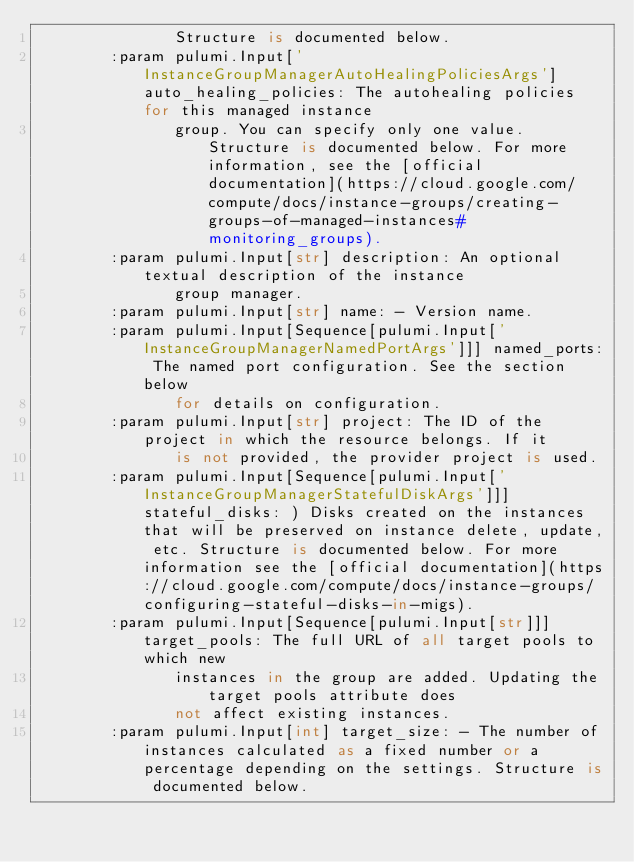Convert code to text. <code><loc_0><loc_0><loc_500><loc_500><_Python_>               Structure is documented below.
        :param pulumi.Input['InstanceGroupManagerAutoHealingPoliciesArgs'] auto_healing_policies: The autohealing policies for this managed instance
               group. You can specify only one value. Structure is documented below. For more information, see the [official documentation](https://cloud.google.com/compute/docs/instance-groups/creating-groups-of-managed-instances#monitoring_groups).
        :param pulumi.Input[str] description: An optional textual description of the instance
               group manager.
        :param pulumi.Input[str] name: - Version name.
        :param pulumi.Input[Sequence[pulumi.Input['InstanceGroupManagerNamedPortArgs']]] named_ports: The named port configuration. See the section below
               for details on configuration.
        :param pulumi.Input[str] project: The ID of the project in which the resource belongs. If it
               is not provided, the provider project is used.
        :param pulumi.Input[Sequence[pulumi.Input['InstanceGroupManagerStatefulDiskArgs']]] stateful_disks: ) Disks created on the instances that will be preserved on instance delete, update, etc. Structure is documented below. For more information see the [official documentation](https://cloud.google.com/compute/docs/instance-groups/configuring-stateful-disks-in-migs).
        :param pulumi.Input[Sequence[pulumi.Input[str]]] target_pools: The full URL of all target pools to which new
               instances in the group are added. Updating the target pools attribute does
               not affect existing instances.
        :param pulumi.Input[int] target_size: - The number of instances calculated as a fixed number or a percentage depending on the settings. Structure is documented below.</code> 